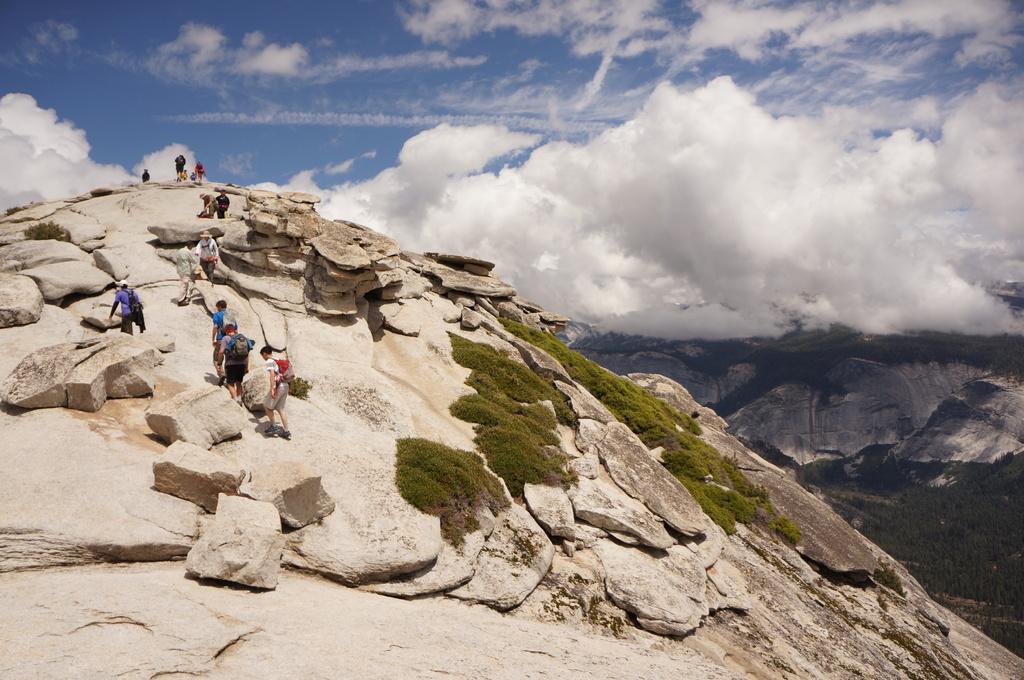Can you describe this image briefly? In this picture of a mountain. In this image there are group of people climbing the mountain and there are plants. At the back there are mountains and trees. At the top there is sky and there are clouds. 